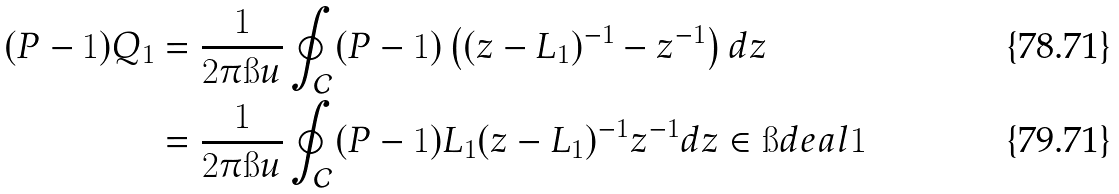<formula> <loc_0><loc_0><loc_500><loc_500>( P - 1 ) Q _ { 1 } & = \frac { 1 } { 2 \pi \i u } \oint _ { \mathcal { C } } ( P - 1 ) \left ( ( z - L _ { 1 } ) ^ { - 1 } - z ^ { - 1 } \right ) d z \\ & = \frac { 1 } { 2 \pi \i u } \oint _ { \mathcal { C } } ( P - 1 ) L _ { 1 } ( z - L _ { 1 } ) ^ { - 1 } z ^ { - 1 } d z \in \i d e a l { 1 }</formula> 